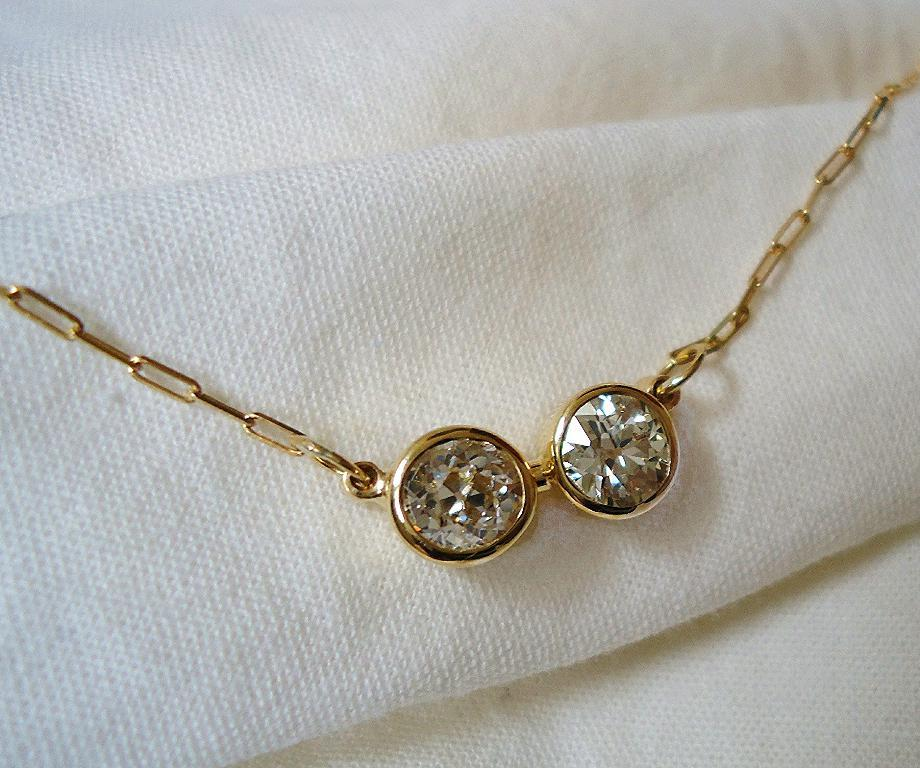What is the main subject of the image? The main subject of the image is a golden color ornament. What is the ornament placed on? The ornament is placed on a white color cloth. How many balls are visible in the image? There are no balls visible in the image; it features a golden color ornament placed on a white color cloth. What is the duration of the event happening in the image? There is no event happening in the image, so it's not possible to determine its duration. 